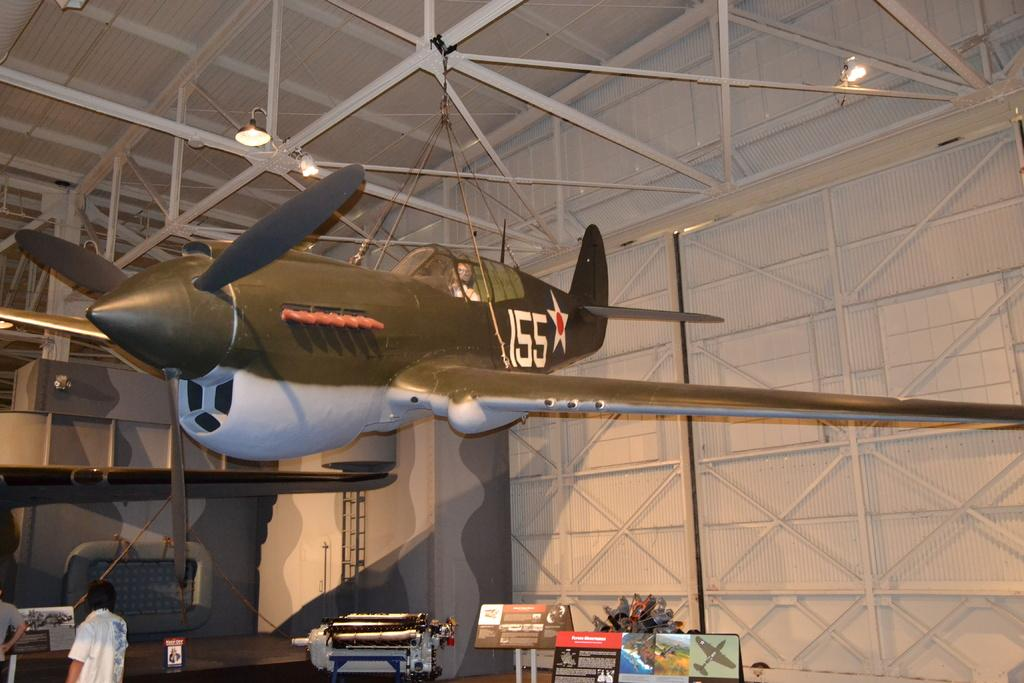<image>
Provide a brief description of the given image. An old fighter plane with the number 155 hangs from a ceiling. 